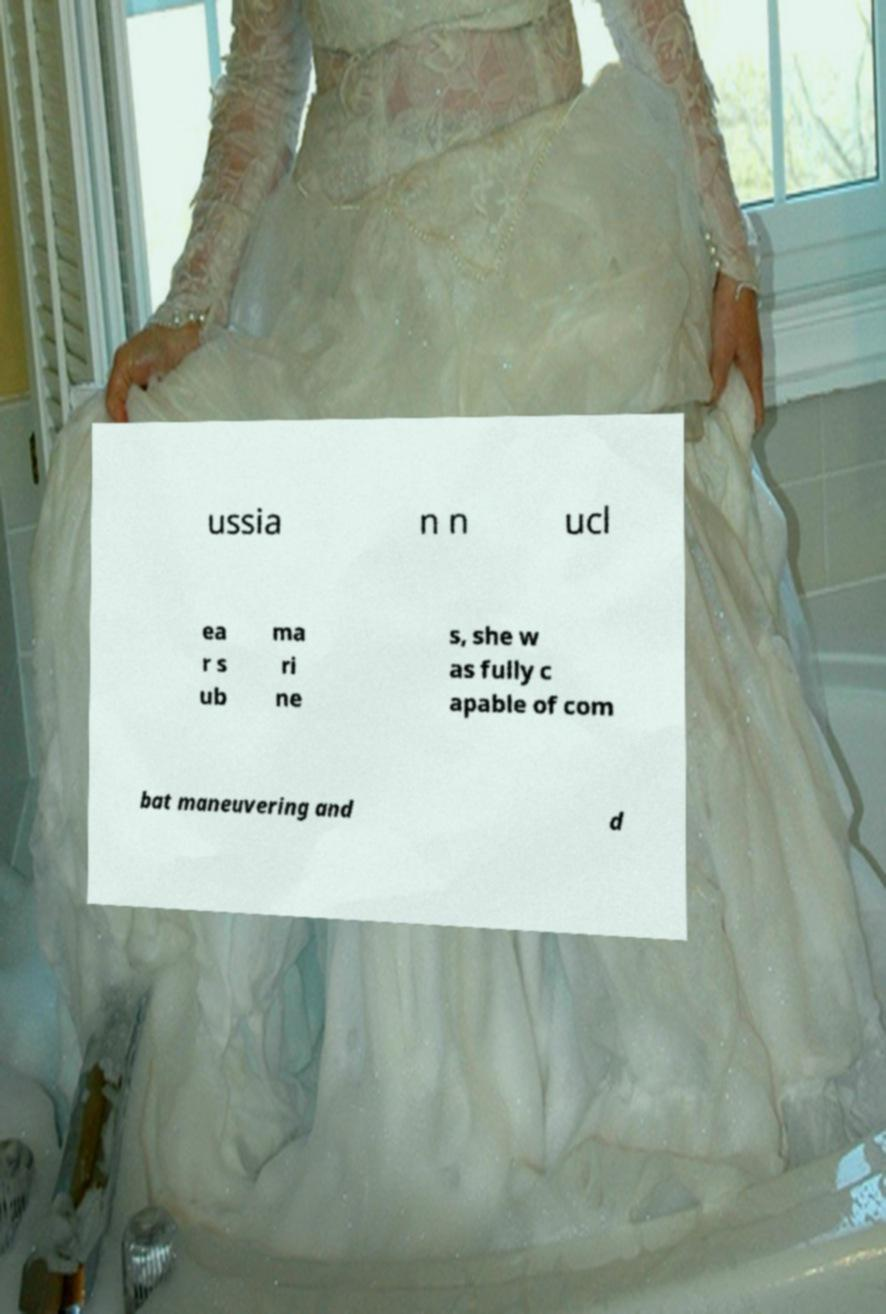For documentation purposes, I need the text within this image transcribed. Could you provide that? ussia n n ucl ea r s ub ma ri ne s, she w as fully c apable of com bat maneuvering and d 